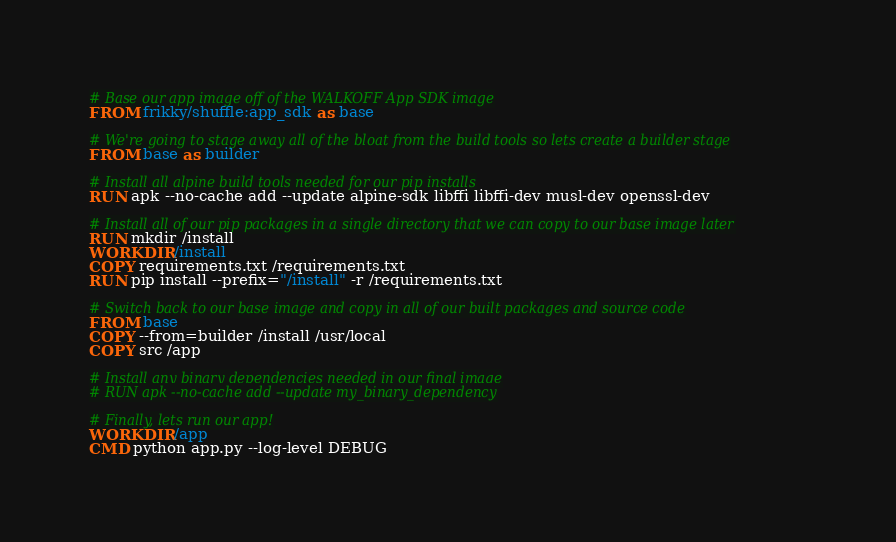Convert code to text. <code><loc_0><loc_0><loc_500><loc_500><_Dockerfile_># Base our app image off of the WALKOFF App SDK image
FROM frikky/shuffle:app_sdk as base

# We're going to stage away all of the bloat from the build tools so lets create a builder stage
FROM base as builder

# Install all alpine build tools needed for our pip installs
RUN apk --no-cache add --update alpine-sdk libffi libffi-dev musl-dev openssl-dev

# Install all of our pip packages in a single directory that we can copy to our base image later
RUN mkdir /install
WORKDIR /install
COPY requirements.txt /requirements.txt
RUN pip install --prefix="/install" -r /requirements.txt

# Switch back to our base image and copy in all of our built packages and source code
FROM base
COPY --from=builder /install /usr/local
COPY src /app

# Install any binary dependencies needed in our final image
# RUN apk --no-cache add --update my_binary_dependency

# Finally, lets run our app!
WORKDIR /app
CMD python app.py --log-level DEBUG</code> 